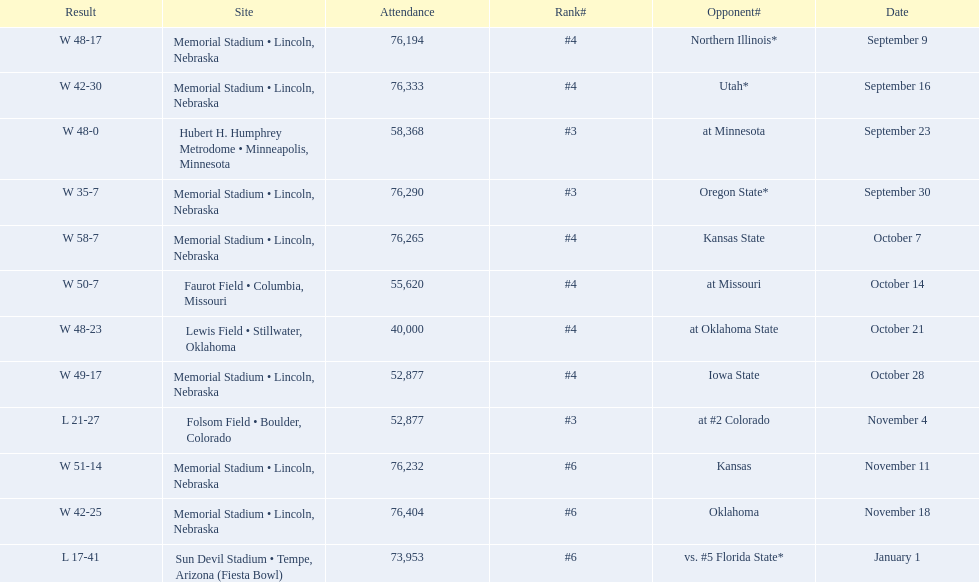Which opponenets did the nebraska cornhuskers score fewer than 40 points against? Oregon State*, at #2 Colorado, vs. #5 Florida State*. Of these games, which ones had an attendance of greater than 70,000? Oregon State*, vs. #5 Florida State*. Which of these opponents did they beat? Oregon State*. How many people were in attendance at that game? 76,290. 